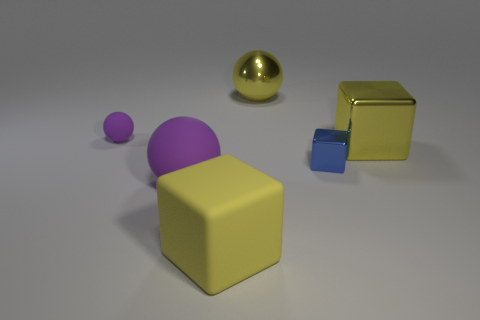What is the material of the purple object that is in front of the metallic block behind the tiny blue metallic cube?
Give a very brief answer. Rubber. The thing that is both on the right side of the matte block and in front of the big metallic block has what shape?
Ensure brevity in your answer.  Cube. What number of other things are the same color as the large metallic ball?
Provide a short and direct response. 2. What number of things are either things that are on the right side of the tiny metal thing or purple matte objects?
Ensure brevity in your answer.  3. Is the color of the large shiny sphere the same as the big sphere in front of the small matte ball?
Ensure brevity in your answer.  No. Are there any other things that have the same size as the yellow metallic block?
Keep it short and to the point. Yes. What is the size of the yellow cube that is behind the yellow rubber block left of the small blue block?
Provide a succinct answer. Large. How many things are big blue shiny spheres or big yellow things behind the large yellow rubber cube?
Your answer should be very brief. 2. Is the shape of the big shiny thing that is on the right side of the small blue metallic object the same as  the tiny blue metal object?
Make the answer very short. Yes. What number of purple matte spheres are in front of the big thing that is on the left side of the large yellow block that is left of the yellow shiny block?
Your response must be concise. 0. 